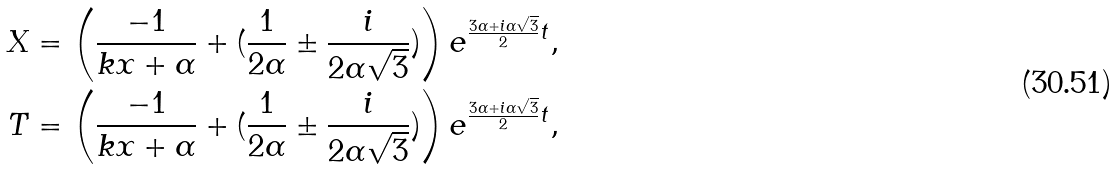<formula> <loc_0><loc_0><loc_500><loc_500>X = \left ( \frac { - 1 } { k x + \alpha } + ( \frac { 1 } { 2 \alpha } \pm \frac { i } { 2 \alpha \sqrt { 3 } } ) \right ) e ^ { \frac { 3 \alpha + i \alpha \sqrt { 3 } } { 2 } t } , \\ T = \left ( \frac { - 1 } { k x + \alpha } + ( \frac { 1 } { 2 \alpha } \pm \frac { i } { 2 \alpha \sqrt { 3 } } ) \right ) e ^ { \frac { 3 \alpha + i \alpha \sqrt { 3 } } { 2 } t } ,</formula> 